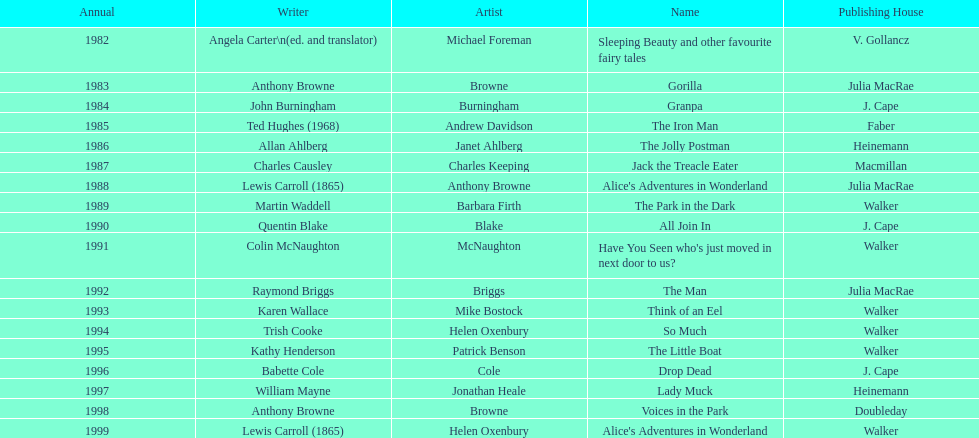How many number of titles are listed for the year 1991? 1. 